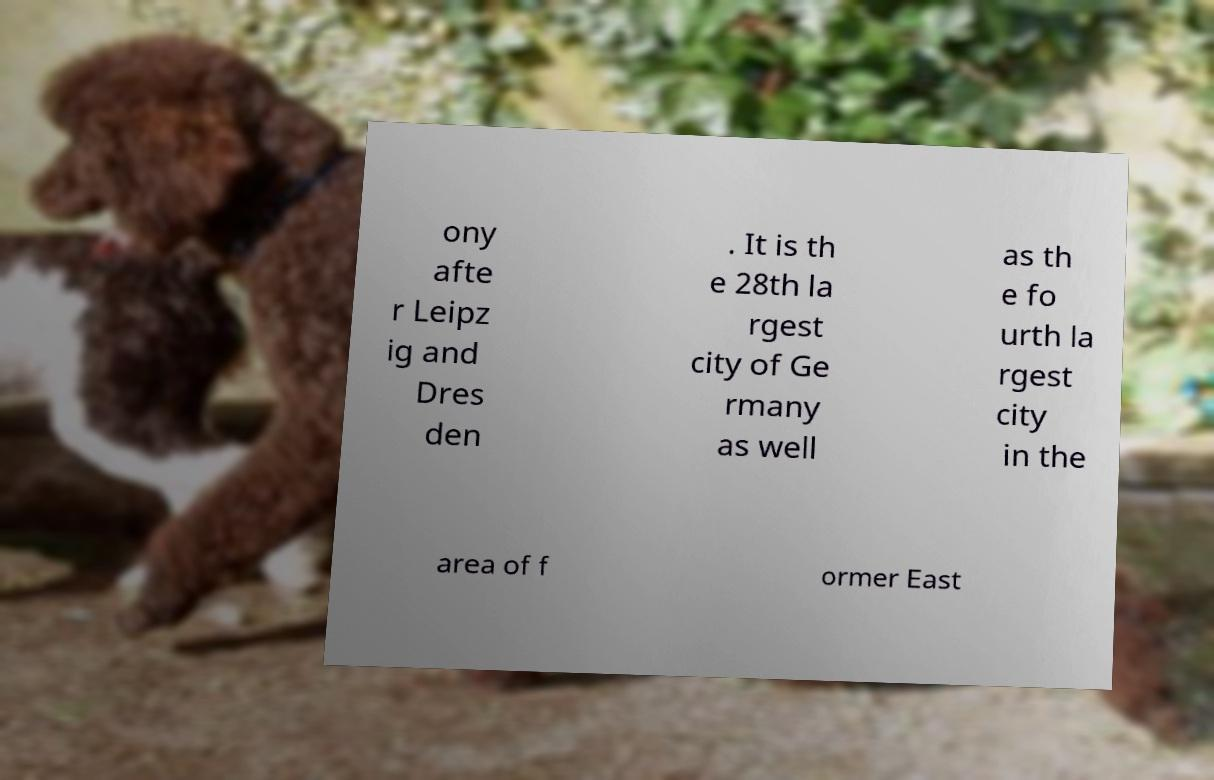What messages or text are displayed in this image? I need them in a readable, typed format. ony afte r Leipz ig and Dres den . It is th e 28th la rgest city of Ge rmany as well as th e fo urth la rgest city in the area of f ormer East 